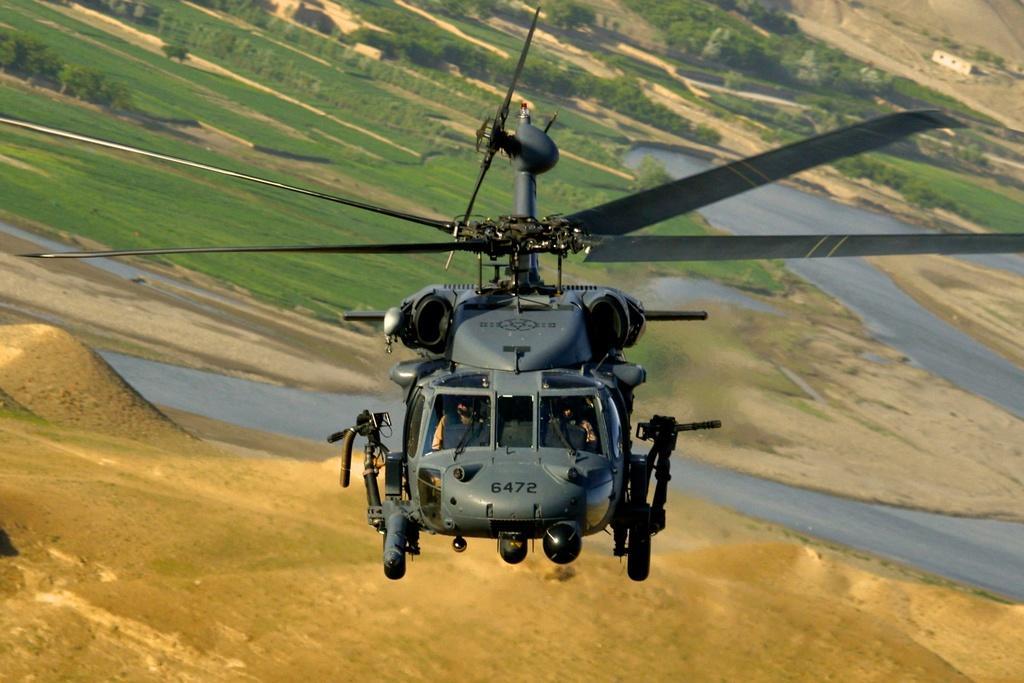In one or two sentences, can you explain what this image depicts? In this picture I can see there is a helicopter and there are guns attached to it. It has wings and there are two persons sitting inside it. In the backdrop I can see there is a grass and trees on the floor. 